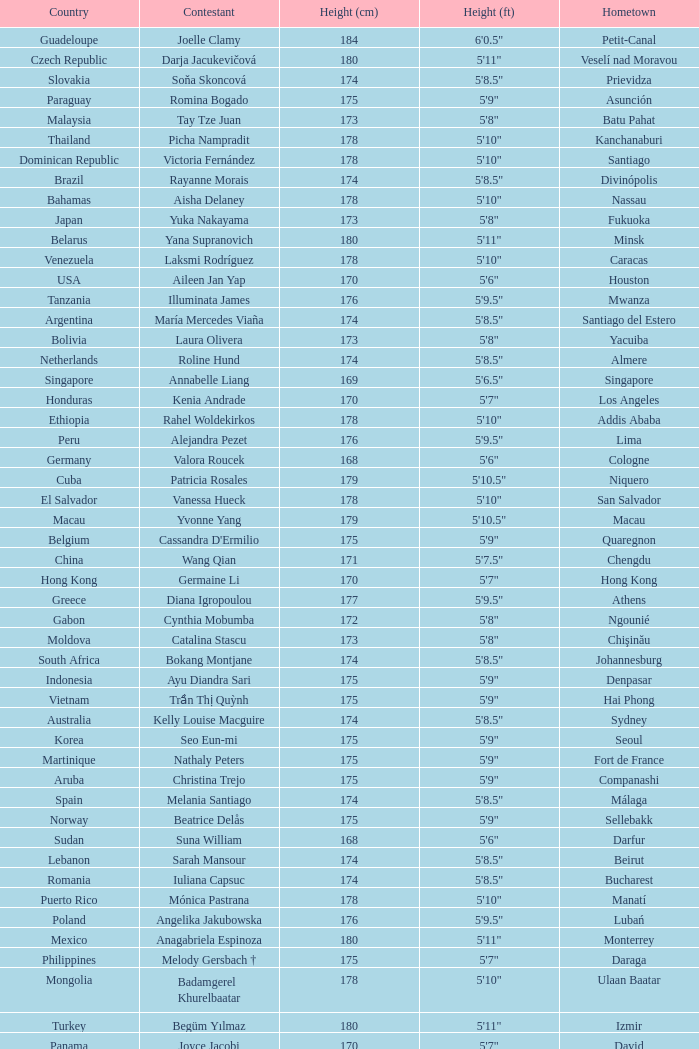What is the hometown of the player from Indonesia? Denpasar. 